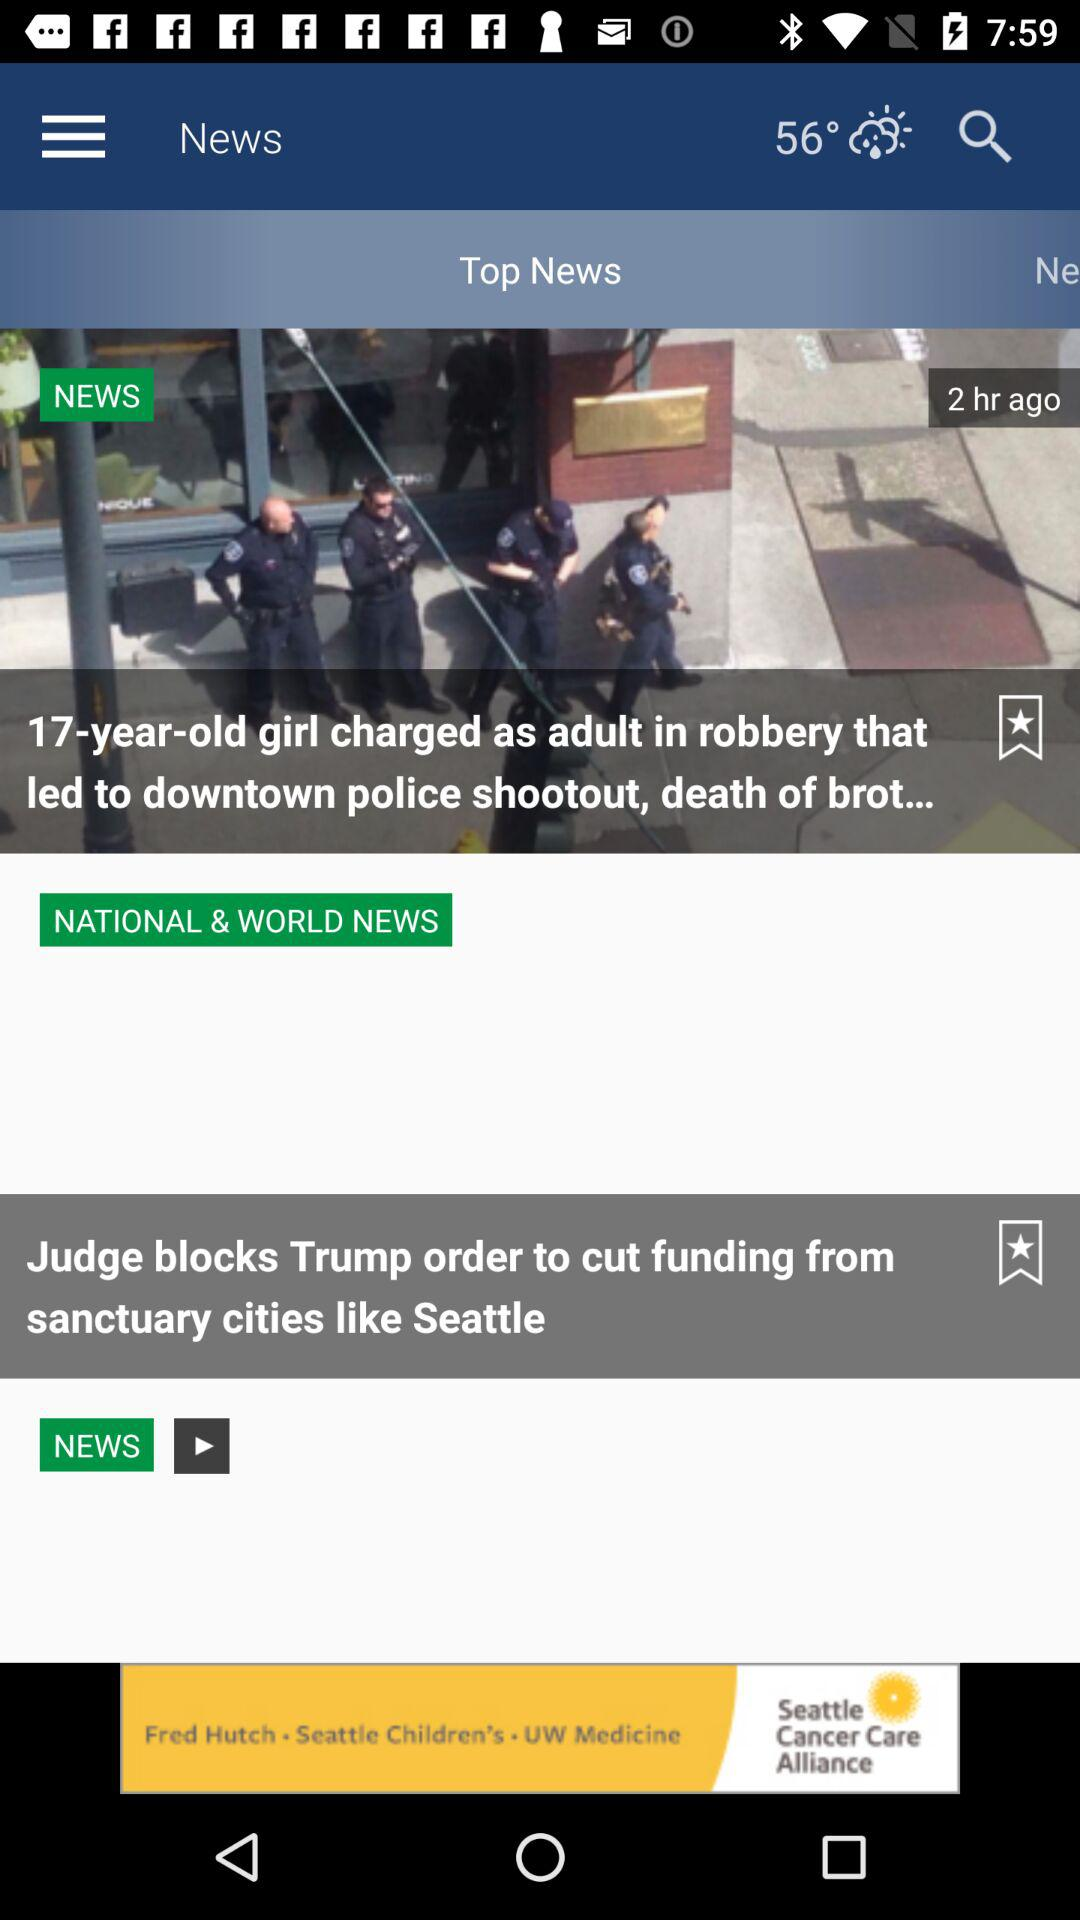What is the temperature? The temperature is 56°. 